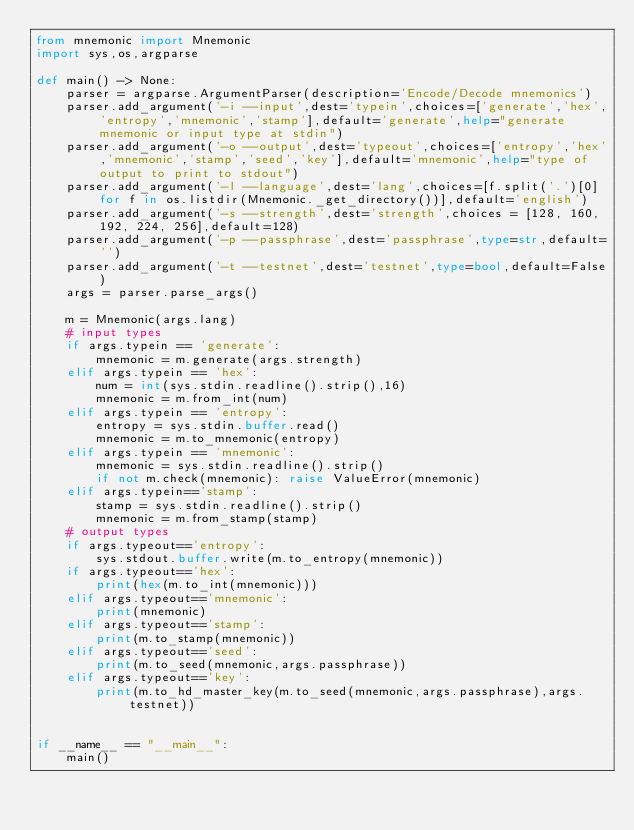Convert code to text. <code><loc_0><loc_0><loc_500><loc_500><_Python_>from mnemonic import Mnemonic
import sys,os,argparse

def main() -> None:
    parser = argparse.ArgumentParser(description='Encode/Decode mnemonics')
    parser.add_argument('-i --input',dest='typein',choices=['generate','hex','entropy','mnemonic','stamp'],default='generate',help="generate mnemonic or input type at stdin")
    parser.add_argument('-o --output',dest='typeout',choices=['entropy','hex','mnemonic','stamp','seed','key'],default='mnemonic',help="type of output to print to stdout")
    parser.add_argument('-l --language',dest='lang',choices=[f.split('.')[0] for f in os.listdir(Mnemonic._get_directory())],default='english')
    parser.add_argument('-s --strength',dest='strength',choices = [128, 160, 192, 224, 256],default=128)
    parser.add_argument('-p --passphrase',dest='passphrase',type=str,default='')
    parser.add_argument('-t --testnet',dest='testnet',type=bool,default=False)
    args = parser.parse_args()

    m = Mnemonic(args.lang)
    # input types
    if args.typein == 'generate':
        mnemonic = m.generate(args.strength)
    elif args.typein == 'hex':
        num = int(sys.stdin.readline().strip(),16)
        mnemonic = m.from_int(num)
    elif args.typein == 'entropy':
        entropy = sys.stdin.buffer.read()
        mnemonic = m.to_mnemonic(entropy)
    elif args.typein == 'mnemonic':
        mnemonic = sys.stdin.readline().strip()
        if not m.check(mnemonic): raise ValueError(mnemonic)
    elif args.typein=='stamp':
        stamp = sys.stdin.readline().strip()
        mnemonic = m.from_stamp(stamp)
    # output types
    if args.typeout=='entropy':
        sys.stdout.buffer.write(m.to_entropy(mnemonic))
    if args.typeout=='hex':
        print(hex(m.to_int(mnemonic)))
    elif args.typeout=='mnemonic':
        print(mnemonic)
    elif args.typeout=='stamp':
        print(m.to_stamp(mnemonic))
    elif args.typeout=='seed':
        print(m.to_seed(mnemonic,args.passphrase))
    elif args.typeout=='key':
        print(m.to_hd_master_key(m.to_seed(mnemonic,args.passphrase),args.testnet))


if __name__ == "__main__":
    main()
</code> 